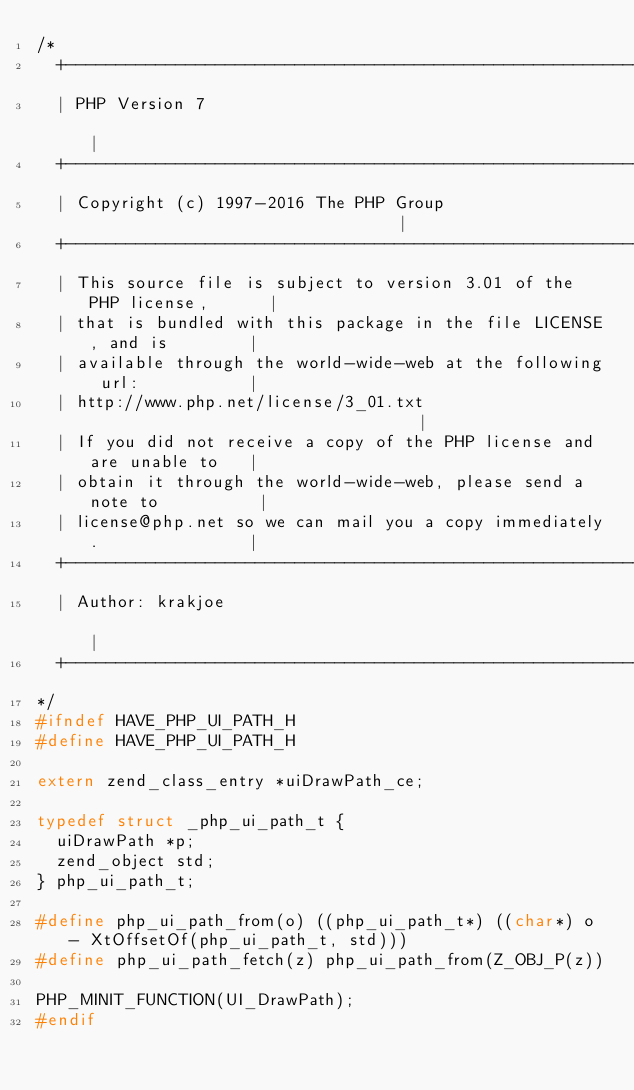Convert code to text. <code><loc_0><loc_0><loc_500><loc_500><_C_>/*
  +----------------------------------------------------------------------+
  | PHP Version 7                                                        |
  +----------------------------------------------------------------------+
  | Copyright (c) 1997-2016 The PHP Group                                |
  +----------------------------------------------------------------------+
  | This source file is subject to version 3.01 of the PHP license,      |
  | that is bundled with this package in the file LICENSE, and is        |
  | available through the world-wide-web at the following url:           |
  | http://www.php.net/license/3_01.txt                                  |
  | If you did not receive a copy of the PHP license and are unable to   |
  | obtain it through the world-wide-web, please send a note to          |
  | license@php.net so we can mail you a copy immediately.               |
  +----------------------------------------------------------------------+
  | Author: krakjoe                                                      |
  +----------------------------------------------------------------------+
*/
#ifndef HAVE_PHP_UI_PATH_H
#define HAVE_PHP_UI_PATH_H

extern zend_class_entry *uiDrawPath_ce;

typedef struct _php_ui_path_t {
	uiDrawPath *p;
	zend_object std;
} php_ui_path_t;

#define php_ui_path_from(o) ((php_ui_path_t*) ((char*) o - XtOffsetOf(php_ui_path_t, std)))
#define php_ui_path_fetch(z) php_ui_path_from(Z_OBJ_P(z))

PHP_MINIT_FUNCTION(UI_DrawPath);
#endif
</code> 